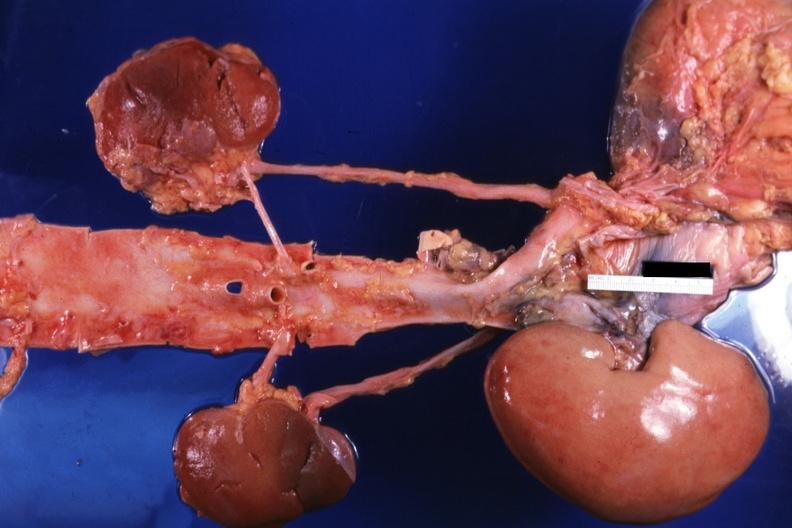how is the transplant placed to other structures?
Answer the question using a single word or phrase. Relative 